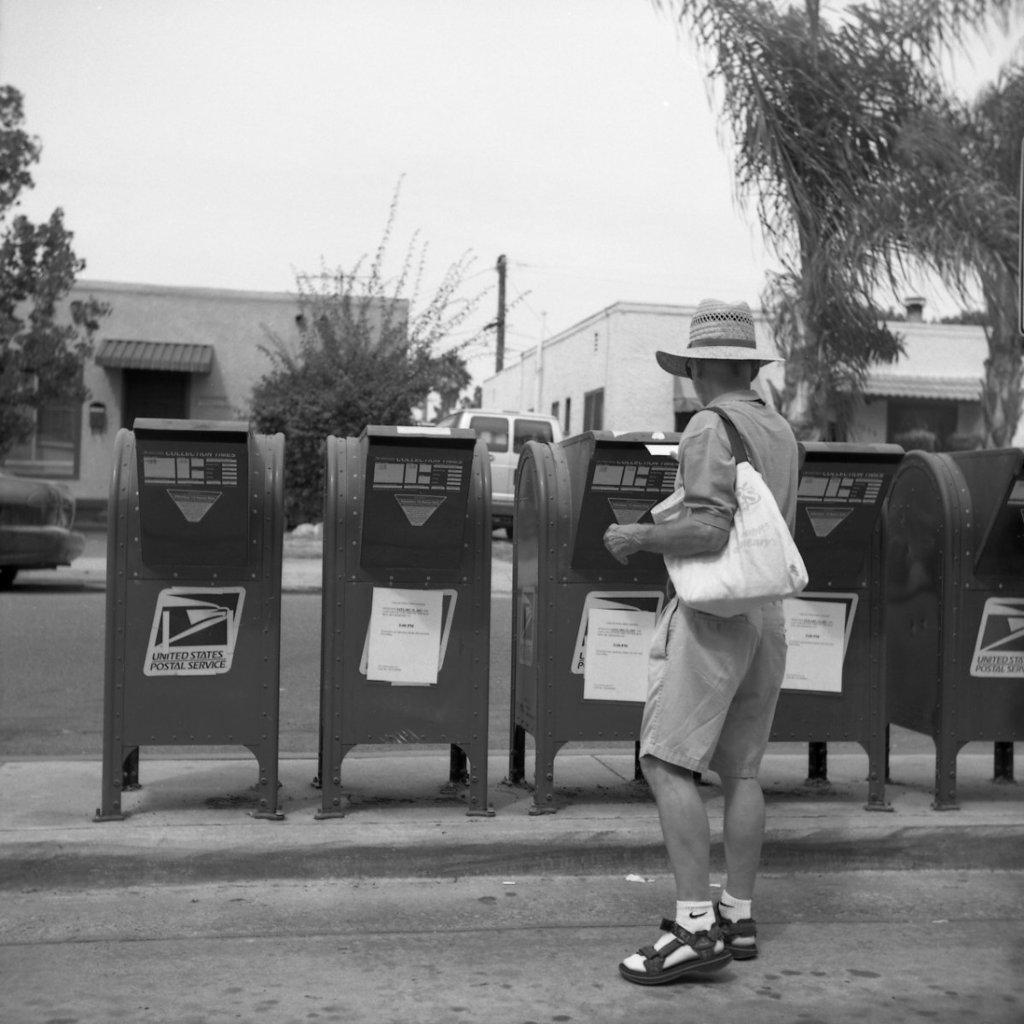<image>
Offer a succinct explanation of the picture presented. Mailman standing in front of a mailbox which says US Postal Services. 